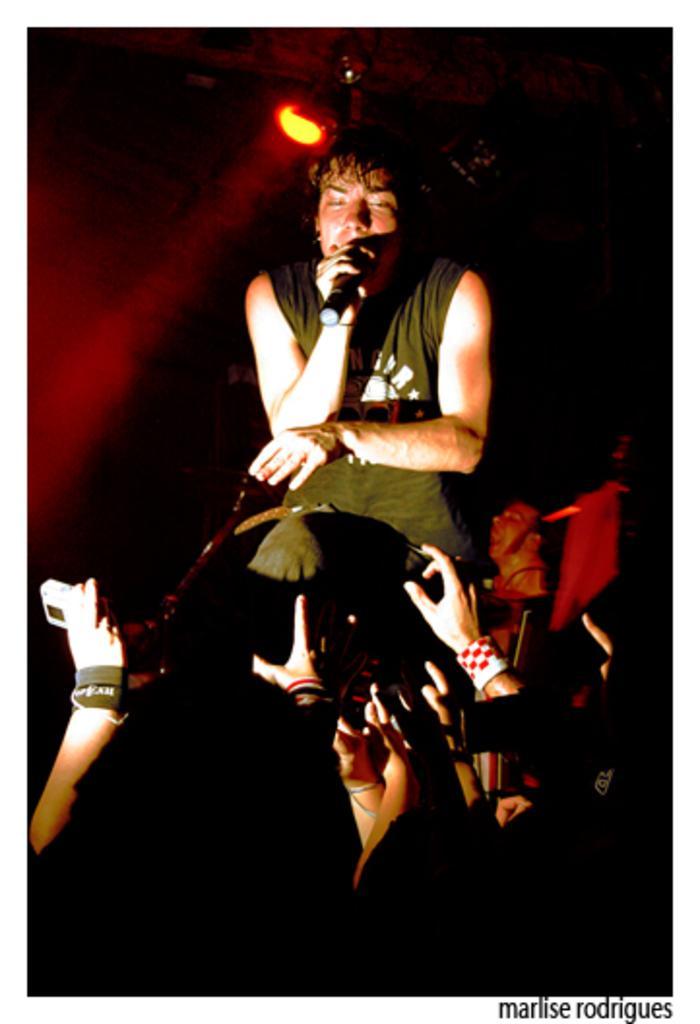Can you describe this image briefly? At the bottom of the image are hands of persons. In front of them there is a man standing and holding a mic in the hand. Behind him there is another man. And there is a dark background and also there is a light. In the bottom right corner of the image there is a name. 